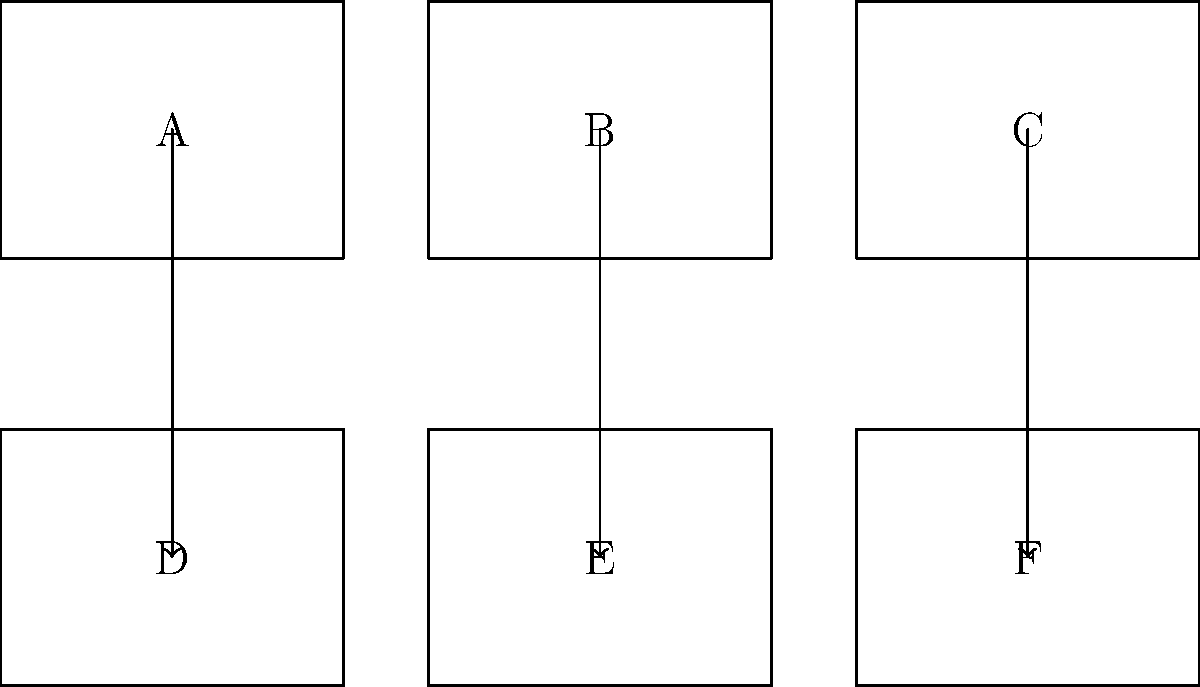As a sequential art expert, arrange the following comic panels in the correct order to form a coherent story. The panels are labeled A through F. What is the correct sequence? To determine the correct sequence of comic panels, we need to analyze the content and flow of each panel:

1. Panel A: Introduction of the main character
2. Panel B: Character encounters a problem
3. Panel C: Character attempts to solve the problem
4. Panel D: Unexpected complication arises
5. Panel E: Character finds a creative solution
6. Panel F: Resolution and conclusion of the story

The logical flow of events suggests the following sequence:

1. Start with panel A to introduce the character
2. Move to panel B for the initial problem
3. Continue with panel C for the first attempt at solving the problem
4. Proceed to panel D for the unexpected complication
5. Follow with panel E for the creative solution
6. End with panel F for the resolution

This sequence (A-B-C-D-E-F) creates a coherent narrative arc, following the classic storytelling structure of introduction, conflict, rising action, climax, and resolution.
Answer: A-B-C-D-E-F 